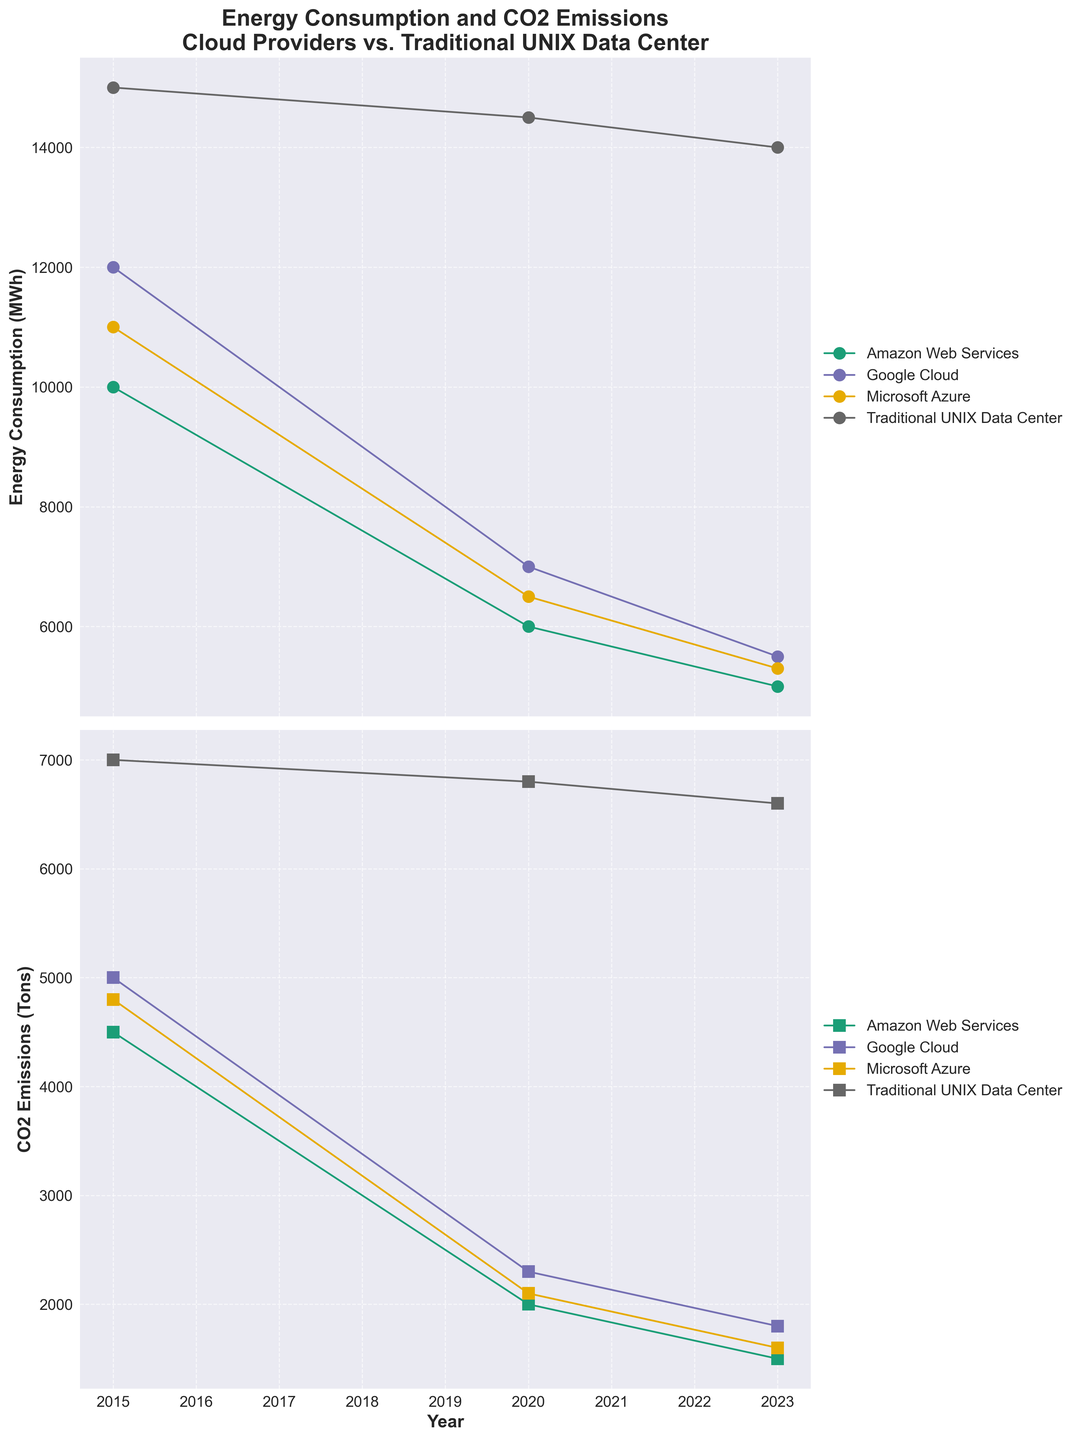What is the title of the plot? The title is displayed at the top of the plot and summarizes the content depicted in the figure. It helps in quickly identifying the subject of the visualization.
Answer: Energy Consumption and CO2 Emissions Cloud Providers vs. Traditional UNIX Data Center What does the y-axis of the first subplot represent? The label next to the y-axis of the first subplot indicates what data is being represented on this axis. This provides context to the plotted points and lines.
Answer: Energy Consumption (MWh) Which cloud provider had the highest CO2 emissions in 2023? By looking at the second subplot and finding the highest point for 2023, we can identify the cloud provider associated with it. The legend helps to differentiate the providers by color and marker shape.
Answer: Google Cloud How much energy consumption reduction did Amazon Web Services achieve from 2015 to 2023? To calculate this, find the energy consumption values for Amazon Web Services in both 2015 and 2023, and then subtract the 2023 value from the 2015 value.
Answer: 5000 MWh Which provider saw the largest drop in CO2 emissions between 2015 and 2023? Calculate the difference in CO2 emissions for each provider between 2015 and 2023, then compare these differences to find the largest one.
Answer: Amazon Web Services In which year did traditional UNIX data centers have the highest CO2 emissions? Look at the second subplot and track the emission values for traditional UNIX data centers over the years, identifying which year had the highest value.
Answer: 2015 How does the energy consumption trend of traditional UNIX data centers compare to cloud providers over time? Observe the energy consumption lines for traditional UNIX data centers and the cloud providers in the first subplot, noting their slopes and overall direction. Analyze whether they are increasing or decreasing and the steepness of change.
Answer: Traditional UNIX data centers show a slightly decreasing trend, while cloud providers show a more significant reduction over time What is the average energy consumption of Google Cloud from 2015 to 2023? Sum the energy consumption values for Google Cloud for all the provided years and then divide by the number of years (i.e., 3).
Answer: 8166.67 MWh Which provider had the highest average CO2 emissions across all years? Calculate the average CO2 emissions for each provider by summing their emission values across all the provided years and dividing by the number of years, then compare these averages.
Answer: Traditional UNIX Data Center How much did CO2 emissions for Microsoft Azure decrease from 2015 to 2020? Subtract the CO2 emissions value for Microsoft Azure in 2020 from the value in 2015, giving the decrease amount.
Answer: 2700 tons 